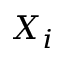Convert formula to latex. <formula><loc_0><loc_0><loc_500><loc_500>X _ { i }</formula> 